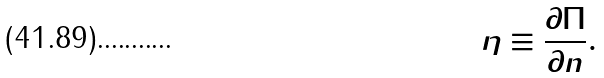Convert formula to latex. <formula><loc_0><loc_0><loc_500><loc_500>\eta \equiv \frac { \partial \Pi } { \partial n } .</formula> 